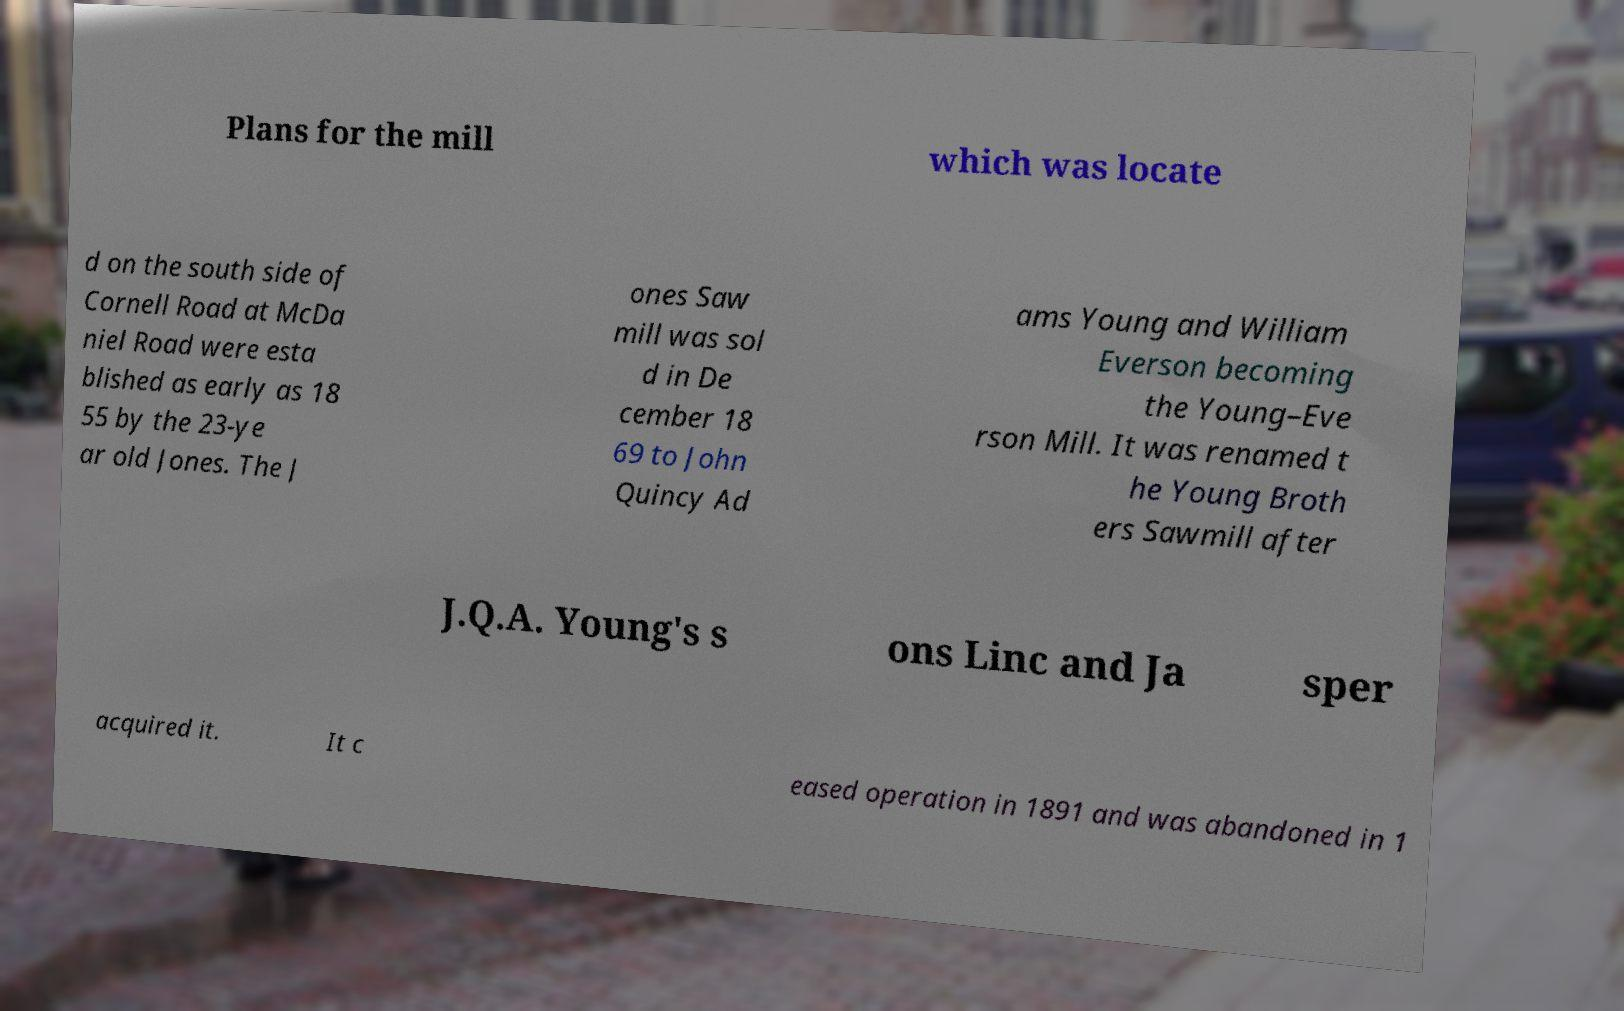Can you read and provide the text displayed in the image?This photo seems to have some interesting text. Can you extract and type it out for me? Plans for the mill which was locate d on the south side of Cornell Road at McDa niel Road were esta blished as early as 18 55 by the 23-ye ar old Jones. The J ones Saw mill was sol d in De cember 18 69 to John Quincy Ad ams Young and William Everson becoming the Young–Eve rson Mill. It was renamed t he Young Broth ers Sawmill after J.Q.A. Young's s ons Linc and Ja sper acquired it. It c eased operation in 1891 and was abandoned in 1 